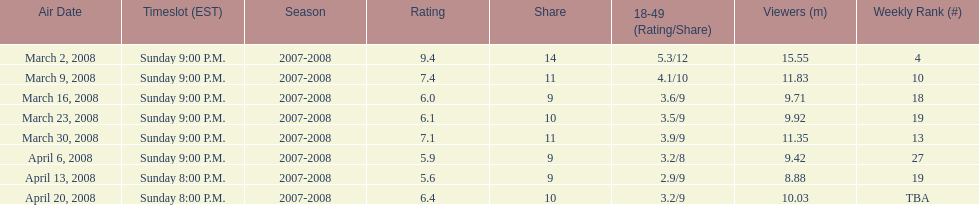Which episode received the top rating? March 2, 2008. Can you give me this table as a dict? {'header': ['Air Date', 'Timeslot (EST)', 'Season', 'Rating', 'Share', '18-49 (Rating/Share)', 'Viewers (m)', 'Weekly Rank (#)'], 'rows': [['March 2, 2008', 'Sunday 9:00 P.M.', '2007-2008', '9.4', '14', '5.3/12', '15.55', '4'], ['March 9, 2008', 'Sunday 9:00 P.M.', '2007-2008', '7.4', '11', '4.1/10', '11.83', '10'], ['March 16, 2008', 'Sunday 9:00 P.M.', '2007-2008', '6.0', '9', '3.6/9', '9.71', '18'], ['March 23, 2008', 'Sunday 9:00 P.M.', '2007-2008', '6.1', '10', '3.5/9', '9.92', '19'], ['March 30, 2008', 'Sunday 9:00 P.M.', '2007-2008', '7.1', '11', '3.9/9', '11.35', '13'], ['April 6, 2008', 'Sunday 9:00 P.M.', '2007-2008', '5.9', '9', '3.2/8', '9.42', '27'], ['April 13, 2008', 'Sunday 8:00 P.M.', '2007-2008', '5.6', '9', '2.9/9', '8.88', '19'], ['April 20, 2008', 'Sunday 8:00 P.M.', '2007-2008', '6.4', '10', '3.2/9', '10.03', 'TBA']]} 